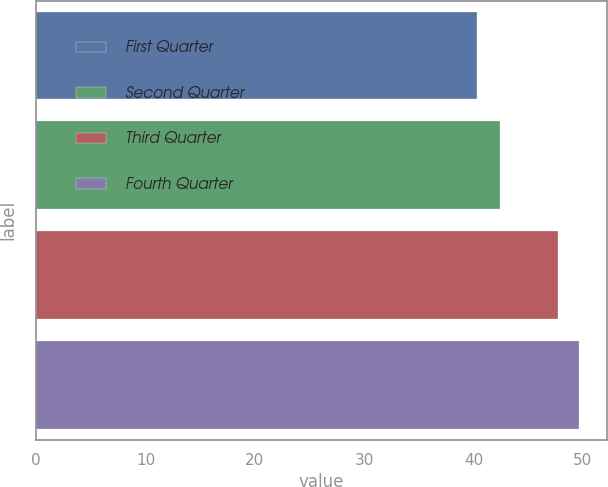Convert chart to OTSL. <chart><loc_0><loc_0><loc_500><loc_500><bar_chart><fcel>First Quarter<fcel>Second Quarter<fcel>Third Quarter<fcel>Fourth Quarter<nl><fcel>40.34<fcel>42.47<fcel>47.74<fcel>49.7<nl></chart> 